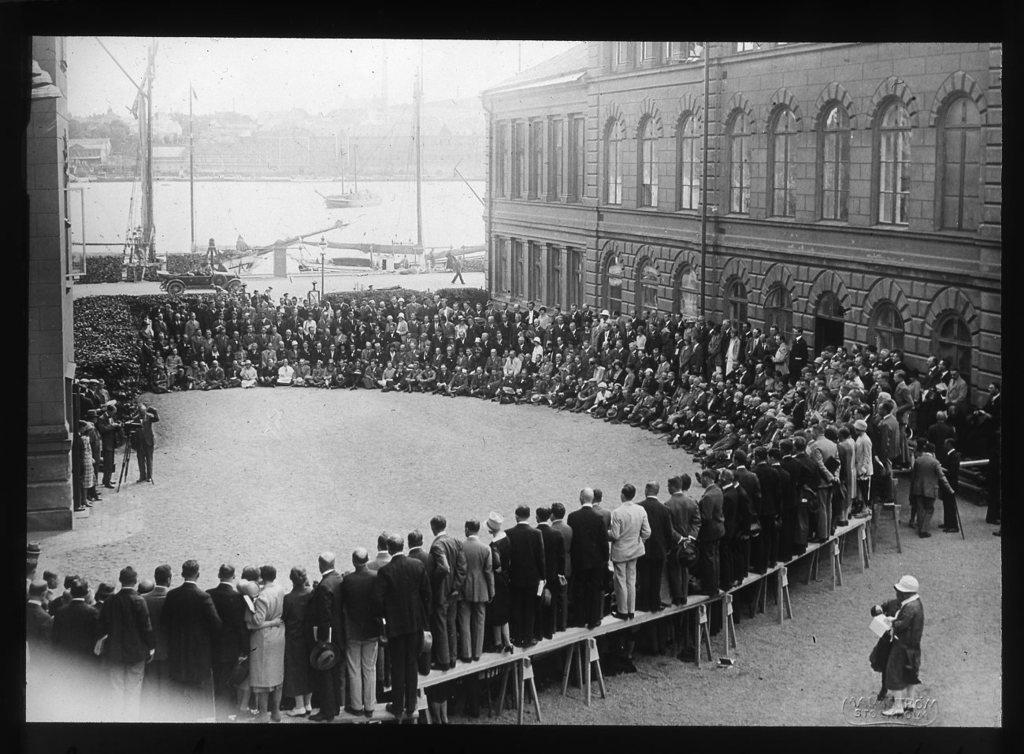How would you summarize this image in a sentence or two? In this image we can see many buildings. There are many people in the image. A person is taking a photo at the left side of the image. There is a pillar at the left side of the image. There are many water crafts in the image. There is a sea in the image. 